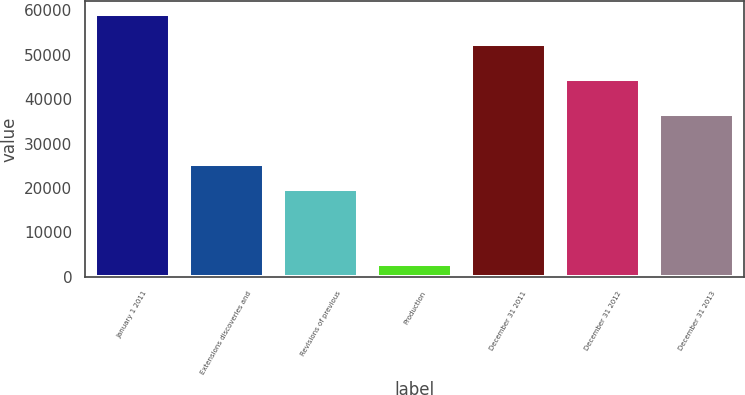Convert chart. <chart><loc_0><loc_0><loc_500><loc_500><bar_chart><fcel>January 1 2011<fcel>Extensions discoveries and<fcel>Revisions of previous<fcel>Production<fcel>December 31 2011<fcel>December 31 2012<fcel>December 31 2013<nl><fcel>59195<fcel>25463.6<fcel>19841.7<fcel>2976<fcel>52391<fcel>44591<fcel>36707.4<nl></chart> 